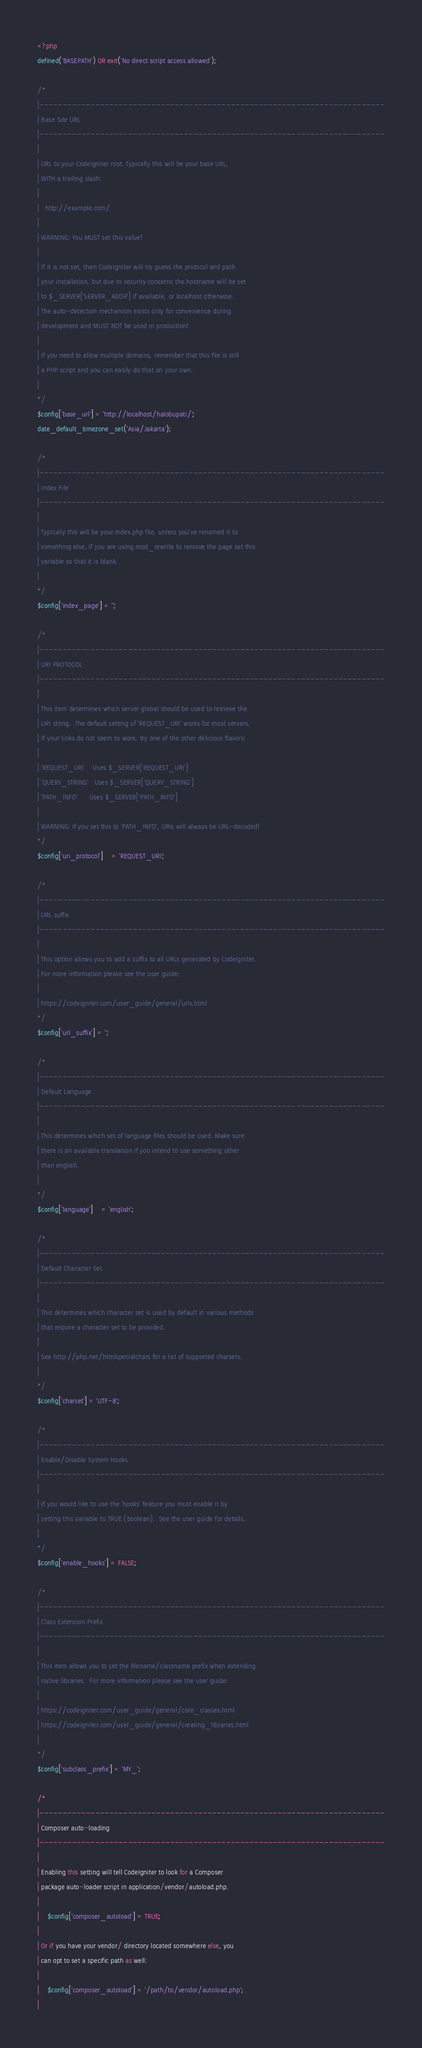Convert code to text. <code><loc_0><loc_0><loc_500><loc_500><_PHP_><?php
defined('BASEPATH') OR exit('No direct script access allowed');

/*
|--------------------------------------------------------------------------
| Base Site URL
|--------------------------------------------------------------------------
|
| URL to your CodeIgniter root. Typically this will be your base URL,
| WITH a trailing slash:
|
|	http://example.com/
|
| WARNING: You MUST set this value!
|
| If it is not set, then CodeIgniter will try guess the protocol and path
| your installation, but due to security concerns the hostname will be set
| to $_SERVER['SERVER_ADDR'] if available, or localhost otherwise.
| The auto-detection mechanism exists only for convenience during
| development and MUST NOT be used in production!
|
| If you need to allow multiple domains, remember that this file is still
| a PHP script and you can easily do that on your own.
|
*/
$config['base_url'] = 'http://localhost/halobupati/';
date_default_timezone_set('Asia/Jakarta');

/*
|--------------------------------------------------------------------------
| Index File
|--------------------------------------------------------------------------
|
| Typically this will be your index.php file, unless you've renamed it to
| something else. If you are using mod_rewrite to remove the page set this
| variable so that it is blank.
|
*/
$config['index_page'] = '';

/*
|--------------------------------------------------------------------------
| URI PROTOCOL
|--------------------------------------------------------------------------
|
| This item determines which server global should be used to retrieve the
| URI string.  The default setting of 'REQUEST_URI' works for most servers.
| If your links do not seem to work, try one of the other delicious flavors:
|
| 'REQUEST_URI'    Uses $_SERVER['REQUEST_URI']
| 'QUERY_STRING'   Uses $_SERVER['QUERY_STRING']
| 'PATH_INFO'      Uses $_SERVER['PATH_INFO']
|
| WARNING: If you set this to 'PATH_INFO', URIs will always be URL-decoded!
*/
$config['uri_protocol']	= 'REQUEST_URI';

/*
|--------------------------------------------------------------------------
| URL suffix
|--------------------------------------------------------------------------
|
| This option allows you to add a suffix to all URLs generated by CodeIgniter.
| For more information please see the user guide:
|
| https://codeigniter.com/user_guide/general/urls.html
*/
$config['url_suffix'] = '';

/*
|--------------------------------------------------------------------------
| Default Language
|--------------------------------------------------------------------------
|
| This determines which set of language files should be used. Make sure
| there is an available translation if you intend to use something other
| than english.
|
*/
$config['language']	= 'english';

/*
|--------------------------------------------------------------------------
| Default Character Set
|--------------------------------------------------------------------------
|
| This determines which character set is used by default in various methods
| that require a character set to be provided.
|
| See http://php.net/htmlspecialchars for a list of supported charsets.
|
*/
$config['charset'] = 'UTF-8';

/*
|--------------------------------------------------------------------------
| Enable/Disable System Hooks
|--------------------------------------------------------------------------
|
| If you would like to use the 'hooks' feature you must enable it by
| setting this variable to TRUE (boolean).  See the user guide for details.
|
*/
$config['enable_hooks'] = FALSE;

/*
|--------------------------------------------------------------------------
| Class Extension Prefix
|--------------------------------------------------------------------------
|
| This item allows you to set the filename/classname prefix when extending
| native libraries.  For more information please see the user guide:
|
| https://codeigniter.com/user_guide/general/core_classes.html
| https://codeigniter.com/user_guide/general/creating_libraries.html
|
*/
$config['subclass_prefix'] = 'MY_';

/*
|--------------------------------------------------------------------------
| Composer auto-loading
|--------------------------------------------------------------------------
|
| Enabling this setting will tell CodeIgniter to look for a Composer
| package auto-loader script in application/vendor/autoload.php.
|
|	$config['composer_autoload'] = TRUE;
|
| Or if you have your vendor/ directory located somewhere else, you
| can opt to set a specific path as well:
|
|	$config['composer_autoload'] = '/path/to/vendor/autoload.php';
|</code> 